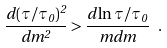Convert formula to latex. <formula><loc_0><loc_0><loc_500><loc_500>\frac { d ( \tau / \tau _ { 0 } ) ^ { 2 } } { d m ^ { 2 } } > \frac { d \ln { \tau / \tau _ { 0 } } } { m d m } \ .</formula> 